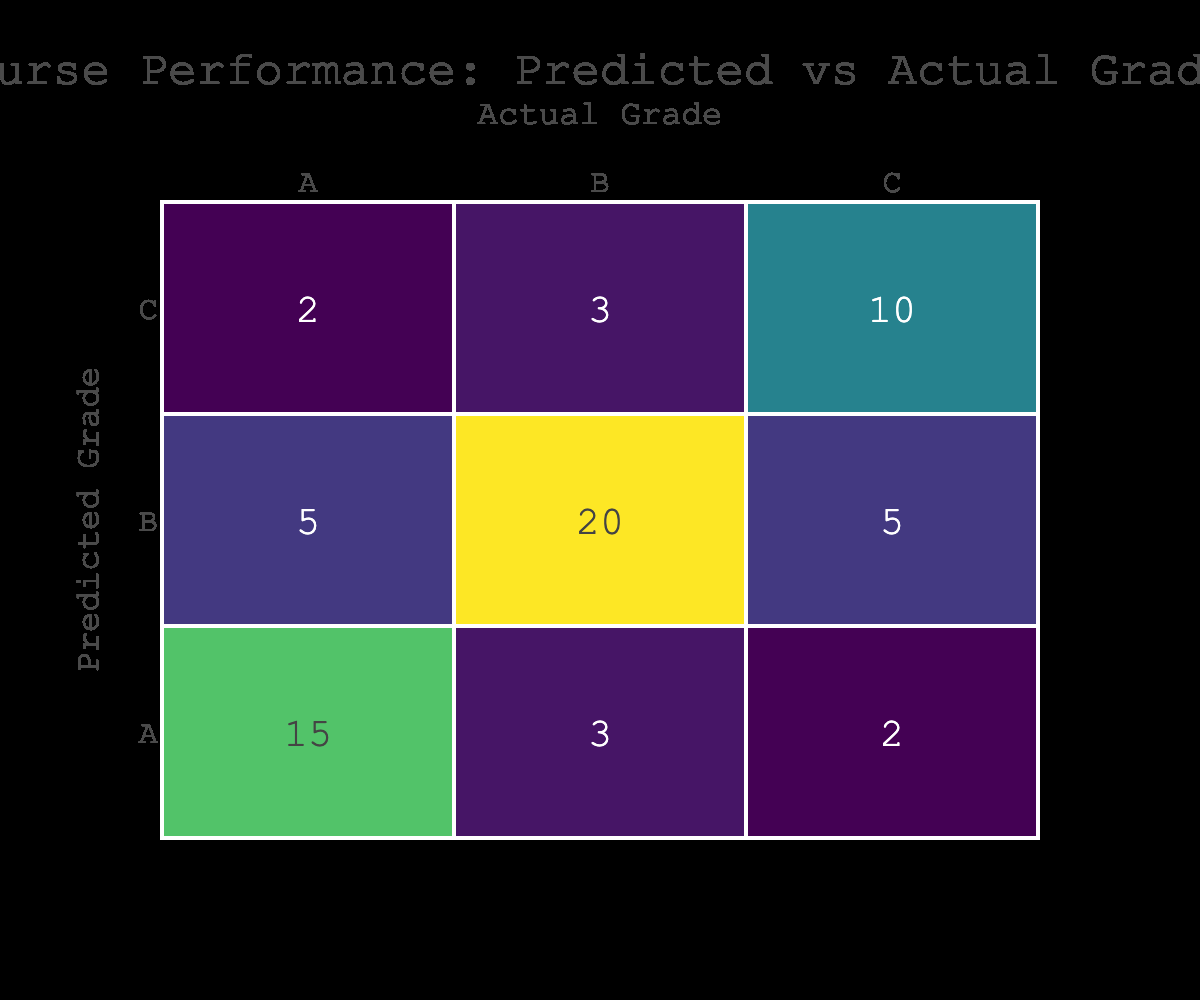What is the count of students who were predicted to receive an A and actually received an A? The table shows that the count of students predicted to receive an A and who actually received an A is directly listed under the cell where both the predicted and actual grade are A. The count there is 15.
Answer: 15 How many students were predicted to receive a B regardless of their actual grade? To find the total number of students predicted to receive a B, we add the counts in the row for predicted grade B: 5 (for B, A) + 20 (for B, B) + 5 (for B, C) = 30.
Answer: 30 Is it true that more students were predicted to receive C than A? To determine this, we compare the total counts: students predicted to receive C are 2 (C, A) + 3 (C, B) + 10 (C, C) = 15. Students predicted to receive A are 15 (A, A) + 3 (A, B) + 2 (A, C) = 20. Since 15 < 20, the statement is false.
Answer: No What is the total number of students who received an actual grade of B? We need to sum all counts in the column where the actual grade is B: 3 (A, B) + 20 (B, B) + 3 (C, B) = 26 students received a B.
Answer: 26 If the predicted grade is A, what percentage of those students got an actual grade of A? The total number of students predicted to receive A is 15 (A, A) + 3 (A, B) + 2 (A, C) = 20. Out of those, 15 actually received an A. The percentage is (15/20) * 100 = 75%.
Answer: 75% How many students received an actual grade of C but were predicted to receive a B? In the table, the count for students who received a C while being predicted a B is found in the corresponding cell, which shows a count of 5 (B, C).
Answer: 5 What is the difference in counts between students who were predicted to get A versus those predicted to get C? The number of students predicted to receive A is 20 (15 + 3 + 2), and for those predicted to receive C is 15 (2 + 3 + 10). The difference is 20 - 15 = 5.
Answer: 5 How many students predicted to receive a B actually got an A? Referring to the counts, the relevant cell for students predicted to get a B but actually got an A shows a count of 5 (B, A).
Answer: 5 What grade had the highest number of students predicted correctly? The highest number of students predicted correctly can be observed in the diagonal of the matrix: A, A (15), B, B (20), and C, C (10). The highest count here is 20 for grade B.
Answer: B 